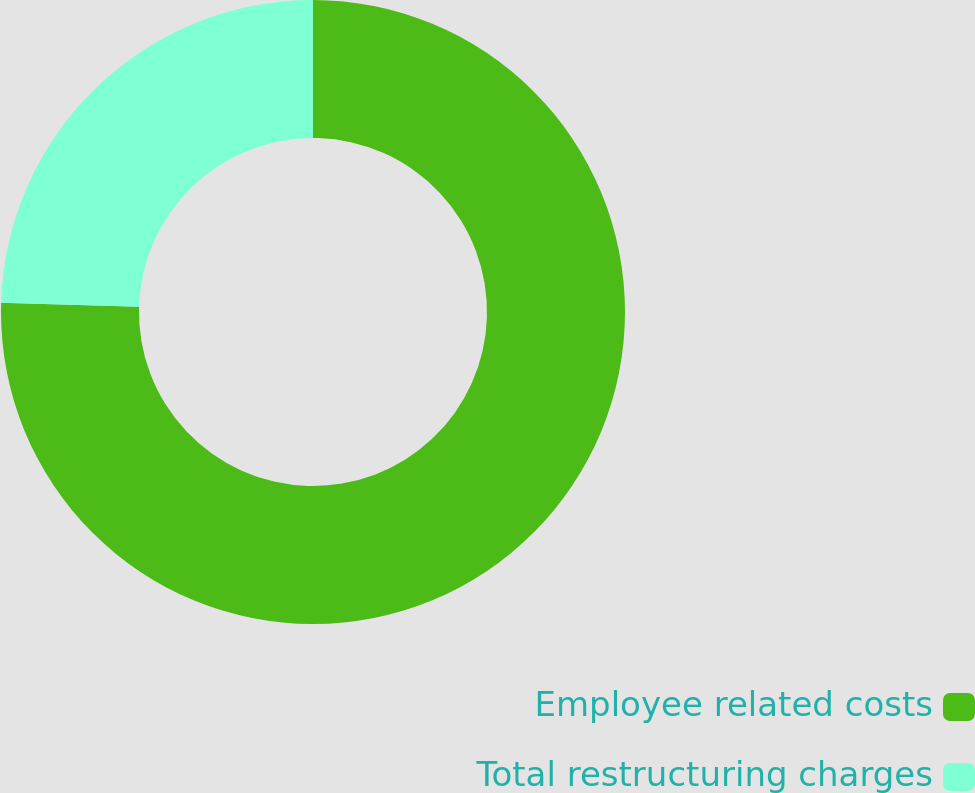Convert chart. <chart><loc_0><loc_0><loc_500><loc_500><pie_chart><fcel>Employee related costs<fcel>Total restructuring charges<nl><fcel>75.47%<fcel>24.53%<nl></chart> 